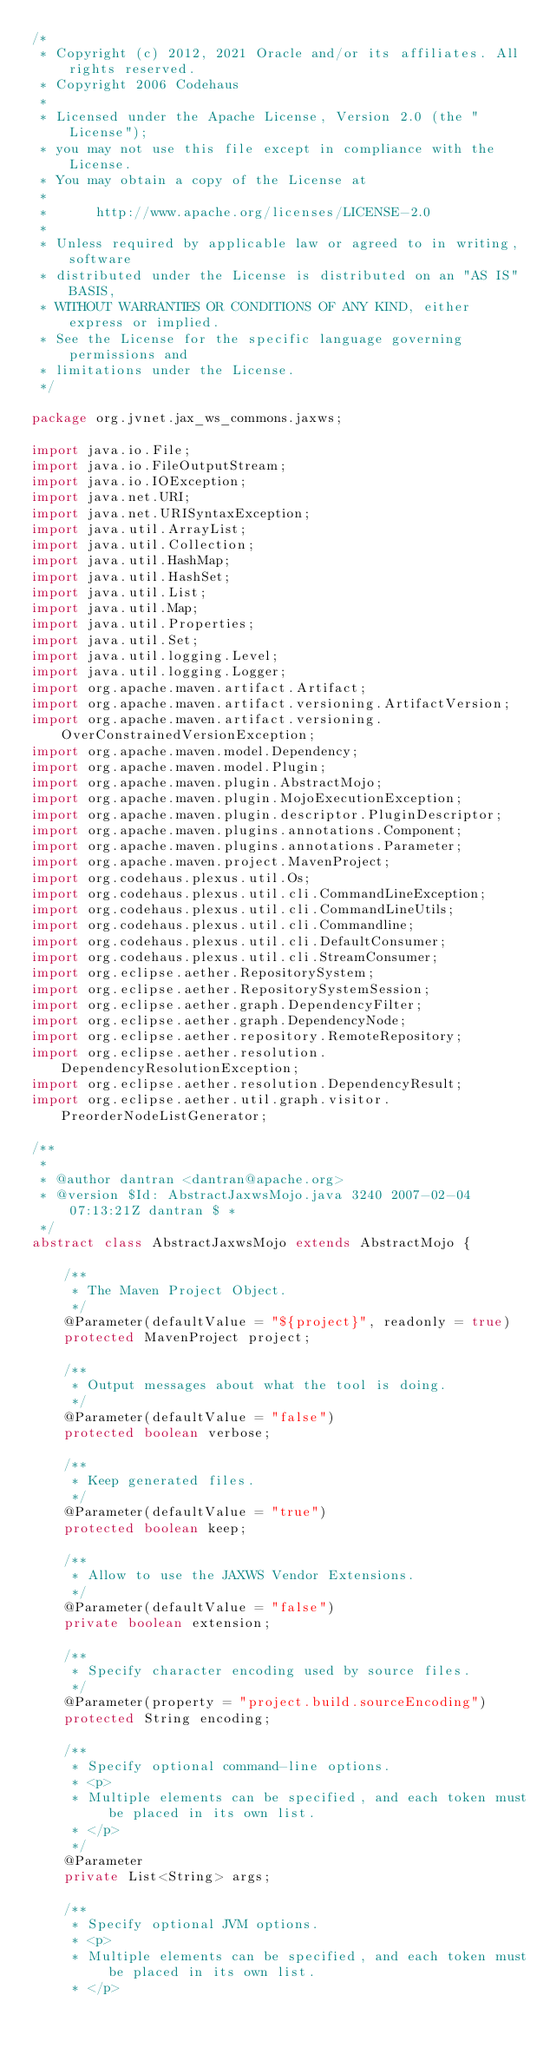Convert code to text. <code><loc_0><loc_0><loc_500><loc_500><_Java_>/*
 * Copyright (c) 2012, 2021 Oracle and/or its affiliates. All rights reserved.
 * Copyright 2006 Codehaus
 *
 * Licensed under the Apache License, Version 2.0 (the "License");
 * you may not use this file except in compliance with the License.
 * You may obtain a copy of the License at
 *
 *      http://www.apache.org/licenses/LICENSE-2.0
 *
 * Unless required by applicable law or agreed to in writing, software
 * distributed under the License is distributed on an "AS IS" BASIS,
 * WITHOUT WARRANTIES OR CONDITIONS OF ANY KIND, either express or implied.
 * See the License for the specific language governing permissions and
 * limitations under the License.
 */

package org.jvnet.jax_ws_commons.jaxws;

import java.io.File;
import java.io.FileOutputStream;
import java.io.IOException;
import java.net.URI;
import java.net.URISyntaxException;
import java.util.ArrayList;
import java.util.Collection;
import java.util.HashMap;
import java.util.HashSet;
import java.util.List;
import java.util.Map;
import java.util.Properties;
import java.util.Set;
import java.util.logging.Level;
import java.util.logging.Logger;
import org.apache.maven.artifact.Artifact;
import org.apache.maven.artifact.versioning.ArtifactVersion;
import org.apache.maven.artifact.versioning.OverConstrainedVersionException;
import org.apache.maven.model.Dependency;
import org.apache.maven.model.Plugin;
import org.apache.maven.plugin.AbstractMojo;
import org.apache.maven.plugin.MojoExecutionException;
import org.apache.maven.plugin.descriptor.PluginDescriptor;
import org.apache.maven.plugins.annotations.Component;
import org.apache.maven.plugins.annotations.Parameter;
import org.apache.maven.project.MavenProject;
import org.codehaus.plexus.util.Os;
import org.codehaus.plexus.util.cli.CommandLineException;
import org.codehaus.plexus.util.cli.CommandLineUtils;
import org.codehaus.plexus.util.cli.Commandline;
import org.codehaus.plexus.util.cli.DefaultConsumer;
import org.codehaus.plexus.util.cli.StreamConsumer;
import org.eclipse.aether.RepositorySystem;
import org.eclipse.aether.RepositorySystemSession;
import org.eclipse.aether.graph.DependencyFilter;
import org.eclipse.aether.graph.DependencyNode;
import org.eclipse.aether.repository.RemoteRepository;
import org.eclipse.aether.resolution.DependencyResolutionException;
import org.eclipse.aether.resolution.DependencyResult;
import org.eclipse.aether.util.graph.visitor.PreorderNodeListGenerator;

/**
 *
 * @author dantran <dantran@apache.org>
 * @version $Id: AbstractJaxwsMojo.java 3240 2007-02-04 07:13:21Z dantran $ *
 */
abstract class AbstractJaxwsMojo extends AbstractMojo {

    /**
     * The Maven Project Object.
     */
    @Parameter(defaultValue = "${project}", readonly = true)
    protected MavenProject project;

    /**
     * Output messages about what the tool is doing.
     */
    @Parameter(defaultValue = "false")
    protected boolean verbose;

    /**
     * Keep generated files.
     */
    @Parameter(defaultValue = "true")
    protected boolean keep;

    /**
     * Allow to use the JAXWS Vendor Extensions.
     */
    @Parameter(defaultValue = "false")
    private boolean extension;

    /**
     * Specify character encoding used by source files.
     */
    @Parameter(property = "project.build.sourceEncoding")
    protected String encoding;

    /**
     * Specify optional command-line options.
     * <p>
     * Multiple elements can be specified, and each token must be placed in its own list.
     * </p>
     */
    @Parameter
    private List<String> args;

    /**
     * Specify optional JVM options.
     * <p>
     * Multiple elements can be specified, and each token must be placed in its own list.
     * </p></code> 